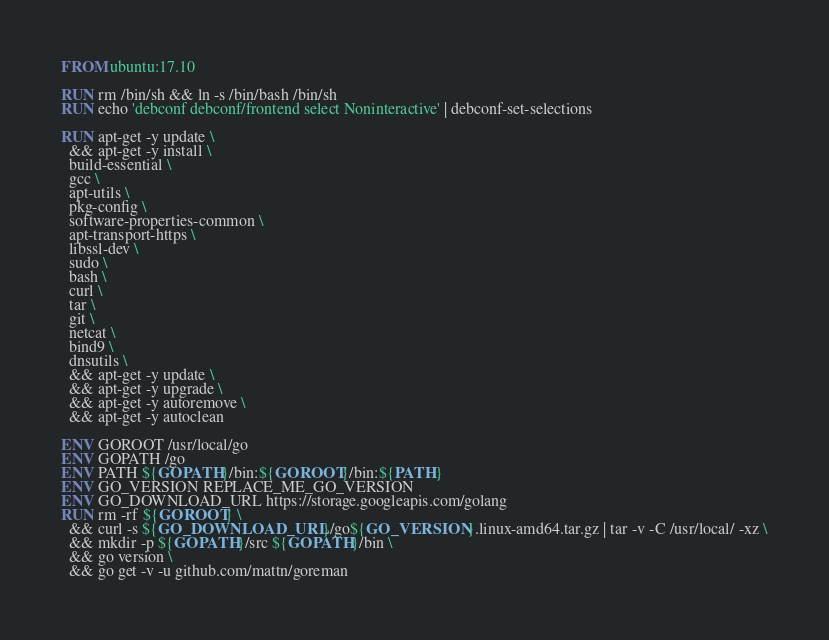<code> <loc_0><loc_0><loc_500><loc_500><_Dockerfile_>FROM ubuntu:17.10

RUN rm /bin/sh && ln -s /bin/bash /bin/sh
RUN echo 'debconf debconf/frontend select Noninteractive' | debconf-set-selections

RUN apt-get -y update \
  && apt-get -y install \
  build-essential \
  gcc \
  apt-utils \
  pkg-config \
  software-properties-common \
  apt-transport-https \
  libssl-dev \
  sudo \
  bash \
  curl \
  tar \
  git \
  netcat \
  bind9 \
  dnsutils \
  && apt-get -y update \
  && apt-get -y upgrade \
  && apt-get -y autoremove \
  && apt-get -y autoclean

ENV GOROOT /usr/local/go
ENV GOPATH /go
ENV PATH ${GOPATH}/bin:${GOROOT}/bin:${PATH}
ENV GO_VERSION REPLACE_ME_GO_VERSION
ENV GO_DOWNLOAD_URL https://storage.googleapis.com/golang
RUN rm -rf ${GOROOT} \
  && curl -s ${GO_DOWNLOAD_URL}/go${GO_VERSION}.linux-amd64.tar.gz | tar -v -C /usr/local/ -xz \
  && mkdir -p ${GOPATH}/src ${GOPATH}/bin \
  && go version \
  && go get -v -u github.com/mattn/goreman
</code> 